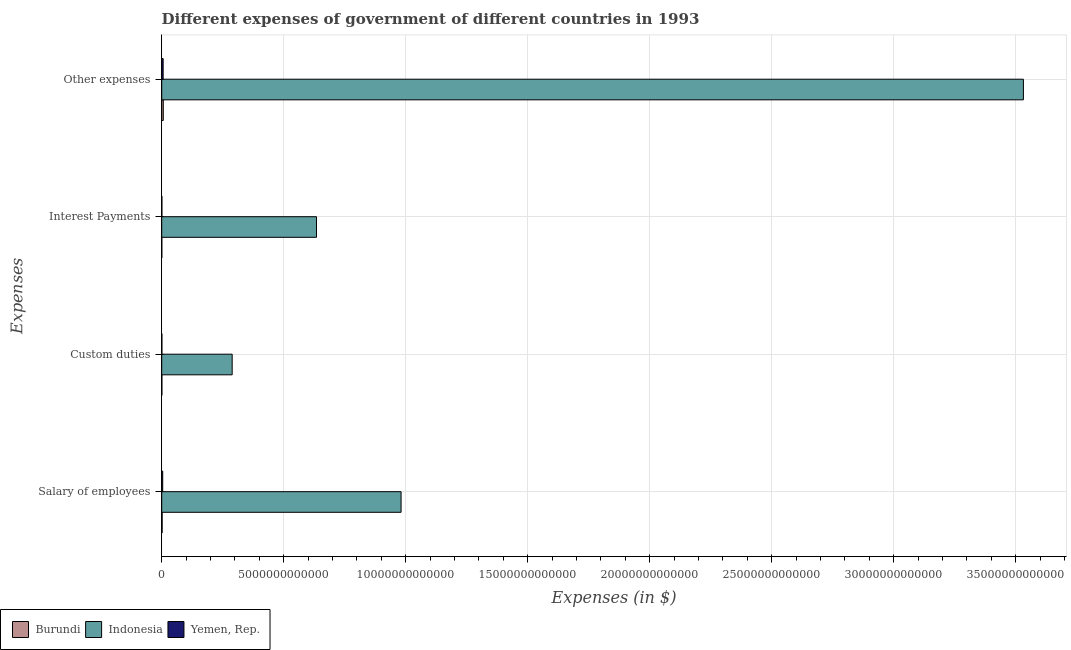How many different coloured bars are there?
Provide a short and direct response. 3. How many groups of bars are there?
Your answer should be very brief. 4. How many bars are there on the 4th tick from the top?
Keep it short and to the point. 3. How many bars are there on the 2nd tick from the bottom?
Give a very brief answer. 3. What is the label of the 4th group of bars from the top?
Make the answer very short. Salary of employees. What is the amount spent on salary of employees in Burundi?
Ensure brevity in your answer.  1.78e+1. Across all countries, what is the maximum amount spent on salary of employees?
Make the answer very short. 9.81e+12. Across all countries, what is the minimum amount spent on custom duties?
Your answer should be very brief. 6.92e+09. In which country was the amount spent on custom duties minimum?
Offer a terse response. Burundi. What is the total amount spent on interest payments in the graph?
Provide a succinct answer. 6.36e+12. What is the difference between the amount spent on custom duties in Yemen, Rep. and that in Burundi?
Ensure brevity in your answer.  6.16e+08. What is the difference between the amount spent on custom duties in Yemen, Rep. and the amount spent on interest payments in Burundi?
Ensure brevity in your answer.  3.58e+09. What is the average amount spent on custom duties per country?
Offer a very short reply. 9.67e+11. What is the difference between the amount spent on other expenses and amount spent on custom duties in Yemen, Rep.?
Ensure brevity in your answer.  5.13e+1. In how many countries, is the amount spent on salary of employees greater than 10000000000000 $?
Your answer should be compact. 0. What is the ratio of the amount spent on custom duties in Yemen, Rep. to that in Indonesia?
Offer a very short reply. 0. Is the amount spent on interest payments in Yemen, Rep. less than that in Burundi?
Offer a very short reply. No. Is the difference between the amount spent on interest payments in Indonesia and Yemen, Rep. greater than the difference between the amount spent on custom duties in Indonesia and Yemen, Rep.?
Ensure brevity in your answer.  Yes. What is the difference between the highest and the second highest amount spent on custom duties?
Offer a very short reply. 2.88e+12. What is the difference between the highest and the lowest amount spent on custom duties?
Your response must be concise. 2.88e+12. In how many countries, is the amount spent on interest payments greater than the average amount spent on interest payments taken over all countries?
Your answer should be compact. 1. Is the sum of the amount spent on other expenses in Burundi and Indonesia greater than the maximum amount spent on interest payments across all countries?
Offer a very short reply. Yes. What does the 3rd bar from the top in Salary of employees represents?
Your answer should be very brief. Burundi. Is it the case that in every country, the sum of the amount spent on salary of employees and amount spent on custom duties is greater than the amount spent on interest payments?
Your response must be concise. Yes. How many bars are there?
Give a very brief answer. 12. What is the difference between two consecutive major ticks on the X-axis?
Offer a very short reply. 5.00e+12. Are the values on the major ticks of X-axis written in scientific E-notation?
Your answer should be compact. No. Does the graph contain any zero values?
Your answer should be compact. No. Where does the legend appear in the graph?
Give a very brief answer. Bottom left. How are the legend labels stacked?
Make the answer very short. Horizontal. What is the title of the graph?
Keep it short and to the point. Different expenses of government of different countries in 1993. Does "Solomon Islands" appear as one of the legend labels in the graph?
Your answer should be very brief. No. What is the label or title of the X-axis?
Give a very brief answer. Expenses (in $). What is the label or title of the Y-axis?
Make the answer very short. Expenses. What is the Expenses (in $) in Burundi in Salary of employees?
Provide a short and direct response. 1.78e+1. What is the Expenses (in $) of Indonesia in Salary of employees?
Give a very brief answer. 9.81e+12. What is the Expenses (in $) of Yemen, Rep. in Salary of employees?
Your answer should be very brief. 4.09e+1. What is the Expenses (in $) of Burundi in Custom duties?
Your answer should be compact. 6.92e+09. What is the Expenses (in $) in Indonesia in Custom duties?
Provide a succinct answer. 2.89e+12. What is the Expenses (in $) in Yemen, Rep. in Custom duties?
Provide a short and direct response. 7.54e+09. What is the Expenses (in $) of Burundi in Interest Payments?
Your answer should be compact. 3.96e+09. What is the Expenses (in $) of Indonesia in Interest Payments?
Make the answer very short. 6.34e+12. What is the Expenses (in $) in Yemen, Rep. in Interest Payments?
Give a very brief answer. 7.23e+09. What is the Expenses (in $) in Burundi in Other expenses?
Give a very brief answer. 6.44e+1. What is the Expenses (in $) of Indonesia in Other expenses?
Give a very brief answer. 3.53e+13. What is the Expenses (in $) in Yemen, Rep. in Other expenses?
Ensure brevity in your answer.  5.88e+1. Across all Expenses, what is the maximum Expenses (in $) of Burundi?
Your answer should be compact. 6.44e+1. Across all Expenses, what is the maximum Expenses (in $) of Indonesia?
Make the answer very short. 3.53e+13. Across all Expenses, what is the maximum Expenses (in $) in Yemen, Rep.?
Provide a short and direct response. 5.88e+1. Across all Expenses, what is the minimum Expenses (in $) in Burundi?
Your answer should be very brief. 3.96e+09. Across all Expenses, what is the minimum Expenses (in $) in Indonesia?
Your answer should be compact. 2.89e+12. Across all Expenses, what is the minimum Expenses (in $) in Yemen, Rep.?
Ensure brevity in your answer.  7.23e+09. What is the total Expenses (in $) of Burundi in the graph?
Your answer should be compact. 9.30e+1. What is the total Expenses (in $) of Indonesia in the graph?
Make the answer very short. 5.44e+13. What is the total Expenses (in $) of Yemen, Rep. in the graph?
Give a very brief answer. 1.14e+11. What is the difference between the Expenses (in $) of Burundi in Salary of employees and that in Custom duties?
Keep it short and to the point. 1.08e+1. What is the difference between the Expenses (in $) in Indonesia in Salary of employees and that in Custom duties?
Offer a terse response. 6.92e+12. What is the difference between the Expenses (in $) in Yemen, Rep. in Salary of employees and that in Custom duties?
Provide a succinct answer. 3.34e+1. What is the difference between the Expenses (in $) of Burundi in Salary of employees and that in Interest Payments?
Provide a short and direct response. 1.38e+1. What is the difference between the Expenses (in $) of Indonesia in Salary of employees and that in Interest Payments?
Your answer should be very brief. 3.47e+12. What is the difference between the Expenses (in $) of Yemen, Rep. in Salary of employees and that in Interest Payments?
Keep it short and to the point. 3.37e+1. What is the difference between the Expenses (in $) in Burundi in Salary of employees and that in Other expenses?
Ensure brevity in your answer.  -4.66e+1. What is the difference between the Expenses (in $) of Indonesia in Salary of employees and that in Other expenses?
Your response must be concise. -2.55e+13. What is the difference between the Expenses (in $) of Yemen, Rep. in Salary of employees and that in Other expenses?
Your response must be concise. -1.79e+1. What is the difference between the Expenses (in $) of Burundi in Custom duties and that in Interest Payments?
Make the answer very short. 2.96e+09. What is the difference between the Expenses (in $) in Indonesia in Custom duties and that in Interest Payments?
Ensure brevity in your answer.  -3.46e+12. What is the difference between the Expenses (in $) in Yemen, Rep. in Custom duties and that in Interest Payments?
Give a very brief answer. 3.06e+08. What is the difference between the Expenses (in $) in Burundi in Custom duties and that in Other expenses?
Offer a terse response. -5.75e+1. What is the difference between the Expenses (in $) of Indonesia in Custom duties and that in Other expenses?
Your response must be concise. -3.24e+13. What is the difference between the Expenses (in $) of Yemen, Rep. in Custom duties and that in Other expenses?
Your answer should be very brief. -5.13e+1. What is the difference between the Expenses (in $) of Burundi in Interest Payments and that in Other expenses?
Ensure brevity in your answer.  -6.04e+1. What is the difference between the Expenses (in $) in Indonesia in Interest Payments and that in Other expenses?
Your answer should be compact. -2.90e+13. What is the difference between the Expenses (in $) of Yemen, Rep. in Interest Payments and that in Other expenses?
Provide a short and direct response. -5.16e+1. What is the difference between the Expenses (in $) of Burundi in Salary of employees and the Expenses (in $) of Indonesia in Custom duties?
Your response must be concise. -2.87e+12. What is the difference between the Expenses (in $) of Burundi in Salary of employees and the Expenses (in $) of Yemen, Rep. in Custom duties?
Offer a very short reply. 1.02e+1. What is the difference between the Expenses (in $) in Indonesia in Salary of employees and the Expenses (in $) in Yemen, Rep. in Custom duties?
Ensure brevity in your answer.  9.80e+12. What is the difference between the Expenses (in $) in Burundi in Salary of employees and the Expenses (in $) in Indonesia in Interest Payments?
Provide a succinct answer. -6.33e+12. What is the difference between the Expenses (in $) of Burundi in Salary of employees and the Expenses (in $) of Yemen, Rep. in Interest Payments?
Offer a terse response. 1.05e+1. What is the difference between the Expenses (in $) of Indonesia in Salary of employees and the Expenses (in $) of Yemen, Rep. in Interest Payments?
Give a very brief answer. 9.80e+12. What is the difference between the Expenses (in $) of Burundi in Salary of employees and the Expenses (in $) of Indonesia in Other expenses?
Your response must be concise. -3.53e+13. What is the difference between the Expenses (in $) of Burundi in Salary of employees and the Expenses (in $) of Yemen, Rep. in Other expenses?
Your answer should be compact. -4.10e+1. What is the difference between the Expenses (in $) of Indonesia in Salary of employees and the Expenses (in $) of Yemen, Rep. in Other expenses?
Your answer should be compact. 9.75e+12. What is the difference between the Expenses (in $) of Burundi in Custom duties and the Expenses (in $) of Indonesia in Interest Payments?
Make the answer very short. -6.34e+12. What is the difference between the Expenses (in $) of Burundi in Custom duties and the Expenses (in $) of Yemen, Rep. in Interest Payments?
Keep it short and to the point. -3.10e+08. What is the difference between the Expenses (in $) of Indonesia in Custom duties and the Expenses (in $) of Yemen, Rep. in Interest Payments?
Give a very brief answer. 2.88e+12. What is the difference between the Expenses (in $) of Burundi in Custom duties and the Expenses (in $) of Indonesia in Other expenses?
Give a very brief answer. -3.53e+13. What is the difference between the Expenses (in $) of Burundi in Custom duties and the Expenses (in $) of Yemen, Rep. in Other expenses?
Make the answer very short. -5.19e+1. What is the difference between the Expenses (in $) of Indonesia in Custom duties and the Expenses (in $) of Yemen, Rep. in Other expenses?
Provide a succinct answer. 2.83e+12. What is the difference between the Expenses (in $) in Burundi in Interest Payments and the Expenses (in $) in Indonesia in Other expenses?
Your response must be concise. -3.53e+13. What is the difference between the Expenses (in $) in Burundi in Interest Payments and the Expenses (in $) in Yemen, Rep. in Other expenses?
Offer a terse response. -5.48e+1. What is the difference between the Expenses (in $) of Indonesia in Interest Payments and the Expenses (in $) of Yemen, Rep. in Other expenses?
Your answer should be compact. 6.29e+12. What is the average Expenses (in $) of Burundi per Expenses?
Keep it short and to the point. 2.33e+1. What is the average Expenses (in $) of Indonesia per Expenses?
Provide a succinct answer. 1.36e+13. What is the average Expenses (in $) of Yemen, Rep. per Expenses?
Make the answer very short. 2.86e+1. What is the difference between the Expenses (in $) of Burundi and Expenses (in $) of Indonesia in Salary of employees?
Give a very brief answer. -9.79e+12. What is the difference between the Expenses (in $) in Burundi and Expenses (in $) in Yemen, Rep. in Salary of employees?
Offer a very short reply. -2.31e+1. What is the difference between the Expenses (in $) in Indonesia and Expenses (in $) in Yemen, Rep. in Salary of employees?
Give a very brief answer. 9.77e+12. What is the difference between the Expenses (in $) in Burundi and Expenses (in $) in Indonesia in Custom duties?
Offer a terse response. -2.88e+12. What is the difference between the Expenses (in $) in Burundi and Expenses (in $) in Yemen, Rep. in Custom duties?
Your answer should be compact. -6.16e+08. What is the difference between the Expenses (in $) of Indonesia and Expenses (in $) of Yemen, Rep. in Custom duties?
Your answer should be compact. 2.88e+12. What is the difference between the Expenses (in $) of Burundi and Expenses (in $) of Indonesia in Interest Payments?
Provide a short and direct response. -6.34e+12. What is the difference between the Expenses (in $) in Burundi and Expenses (in $) in Yemen, Rep. in Interest Payments?
Offer a terse response. -3.27e+09. What is the difference between the Expenses (in $) of Indonesia and Expenses (in $) of Yemen, Rep. in Interest Payments?
Offer a terse response. 6.34e+12. What is the difference between the Expenses (in $) of Burundi and Expenses (in $) of Indonesia in Other expenses?
Give a very brief answer. -3.53e+13. What is the difference between the Expenses (in $) in Burundi and Expenses (in $) in Yemen, Rep. in Other expenses?
Your response must be concise. 5.60e+09. What is the difference between the Expenses (in $) of Indonesia and Expenses (in $) of Yemen, Rep. in Other expenses?
Offer a very short reply. 3.53e+13. What is the ratio of the Expenses (in $) in Burundi in Salary of employees to that in Custom duties?
Provide a succinct answer. 2.57. What is the ratio of the Expenses (in $) in Indonesia in Salary of employees to that in Custom duties?
Provide a succinct answer. 3.4. What is the ratio of the Expenses (in $) of Yemen, Rep. in Salary of employees to that in Custom duties?
Make the answer very short. 5.43. What is the ratio of the Expenses (in $) of Burundi in Salary of employees to that in Interest Payments?
Make the answer very short. 4.49. What is the ratio of the Expenses (in $) of Indonesia in Salary of employees to that in Interest Payments?
Ensure brevity in your answer.  1.55. What is the ratio of the Expenses (in $) in Yemen, Rep. in Salary of employees to that in Interest Payments?
Provide a succinct answer. 5.66. What is the ratio of the Expenses (in $) of Burundi in Salary of employees to that in Other expenses?
Provide a short and direct response. 0.28. What is the ratio of the Expenses (in $) in Indonesia in Salary of employees to that in Other expenses?
Give a very brief answer. 0.28. What is the ratio of the Expenses (in $) in Yemen, Rep. in Salary of employees to that in Other expenses?
Offer a terse response. 0.7. What is the ratio of the Expenses (in $) of Burundi in Custom duties to that in Interest Payments?
Your answer should be very brief. 1.75. What is the ratio of the Expenses (in $) of Indonesia in Custom duties to that in Interest Payments?
Keep it short and to the point. 0.46. What is the ratio of the Expenses (in $) in Yemen, Rep. in Custom duties to that in Interest Payments?
Ensure brevity in your answer.  1.04. What is the ratio of the Expenses (in $) of Burundi in Custom duties to that in Other expenses?
Your response must be concise. 0.11. What is the ratio of the Expenses (in $) of Indonesia in Custom duties to that in Other expenses?
Your answer should be very brief. 0.08. What is the ratio of the Expenses (in $) of Yemen, Rep. in Custom duties to that in Other expenses?
Offer a very short reply. 0.13. What is the ratio of the Expenses (in $) of Burundi in Interest Payments to that in Other expenses?
Provide a succinct answer. 0.06. What is the ratio of the Expenses (in $) in Indonesia in Interest Payments to that in Other expenses?
Your answer should be compact. 0.18. What is the ratio of the Expenses (in $) of Yemen, Rep. in Interest Payments to that in Other expenses?
Your answer should be compact. 0.12. What is the difference between the highest and the second highest Expenses (in $) in Burundi?
Offer a terse response. 4.66e+1. What is the difference between the highest and the second highest Expenses (in $) in Indonesia?
Ensure brevity in your answer.  2.55e+13. What is the difference between the highest and the second highest Expenses (in $) of Yemen, Rep.?
Make the answer very short. 1.79e+1. What is the difference between the highest and the lowest Expenses (in $) of Burundi?
Provide a short and direct response. 6.04e+1. What is the difference between the highest and the lowest Expenses (in $) in Indonesia?
Make the answer very short. 3.24e+13. What is the difference between the highest and the lowest Expenses (in $) of Yemen, Rep.?
Your answer should be compact. 5.16e+1. 